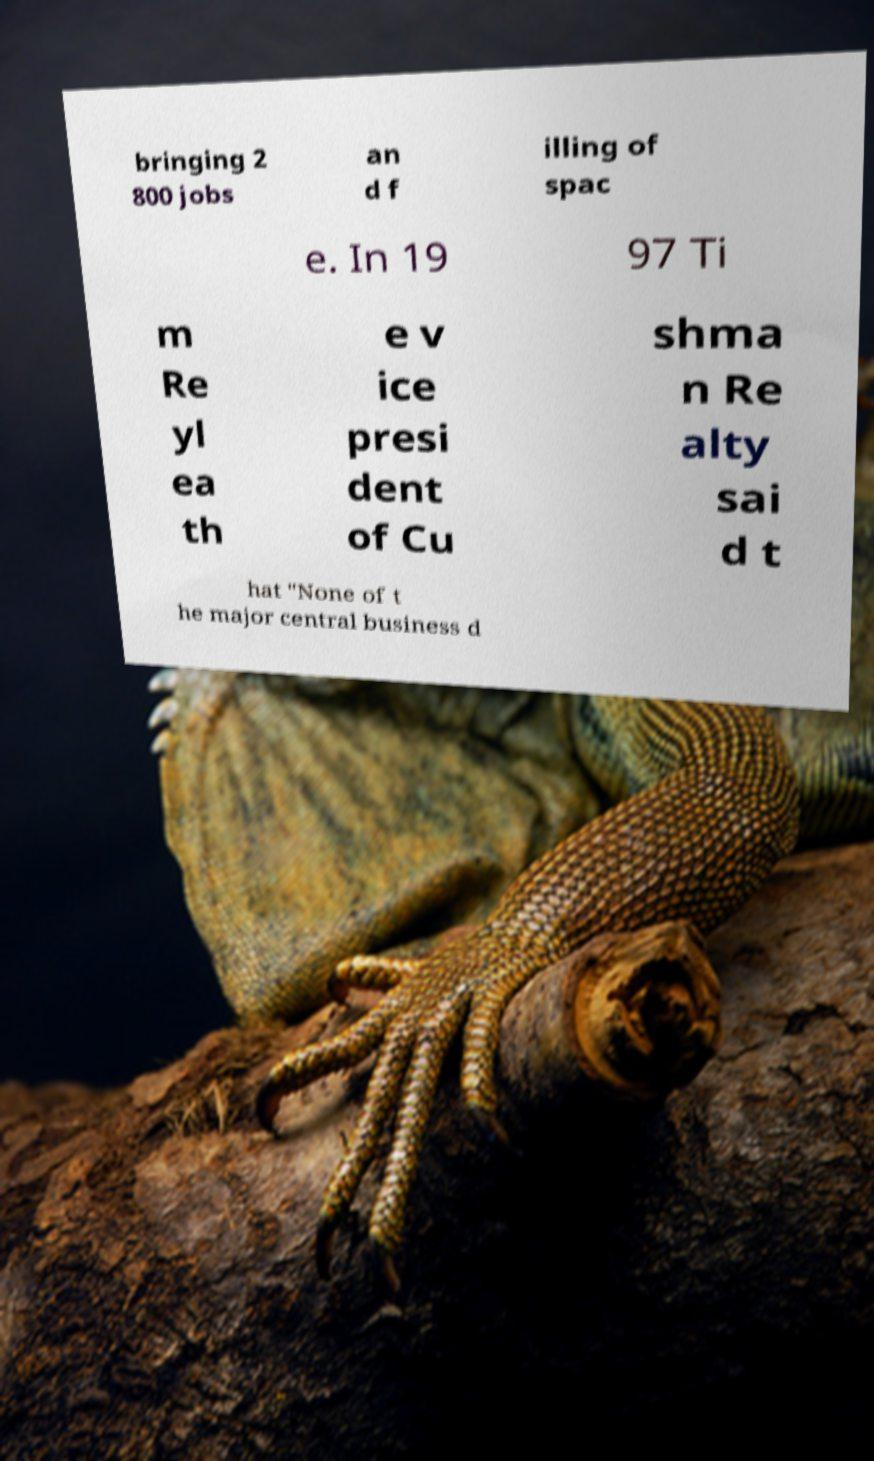Could you extract and type out the text from this image? bringing 2 800 jobs an d f illing of spac e. In 19 97 Ti m Re yl ea th e v ice presi dent of Cu shma n Re alty sai d t hat "None of t he major central business d 